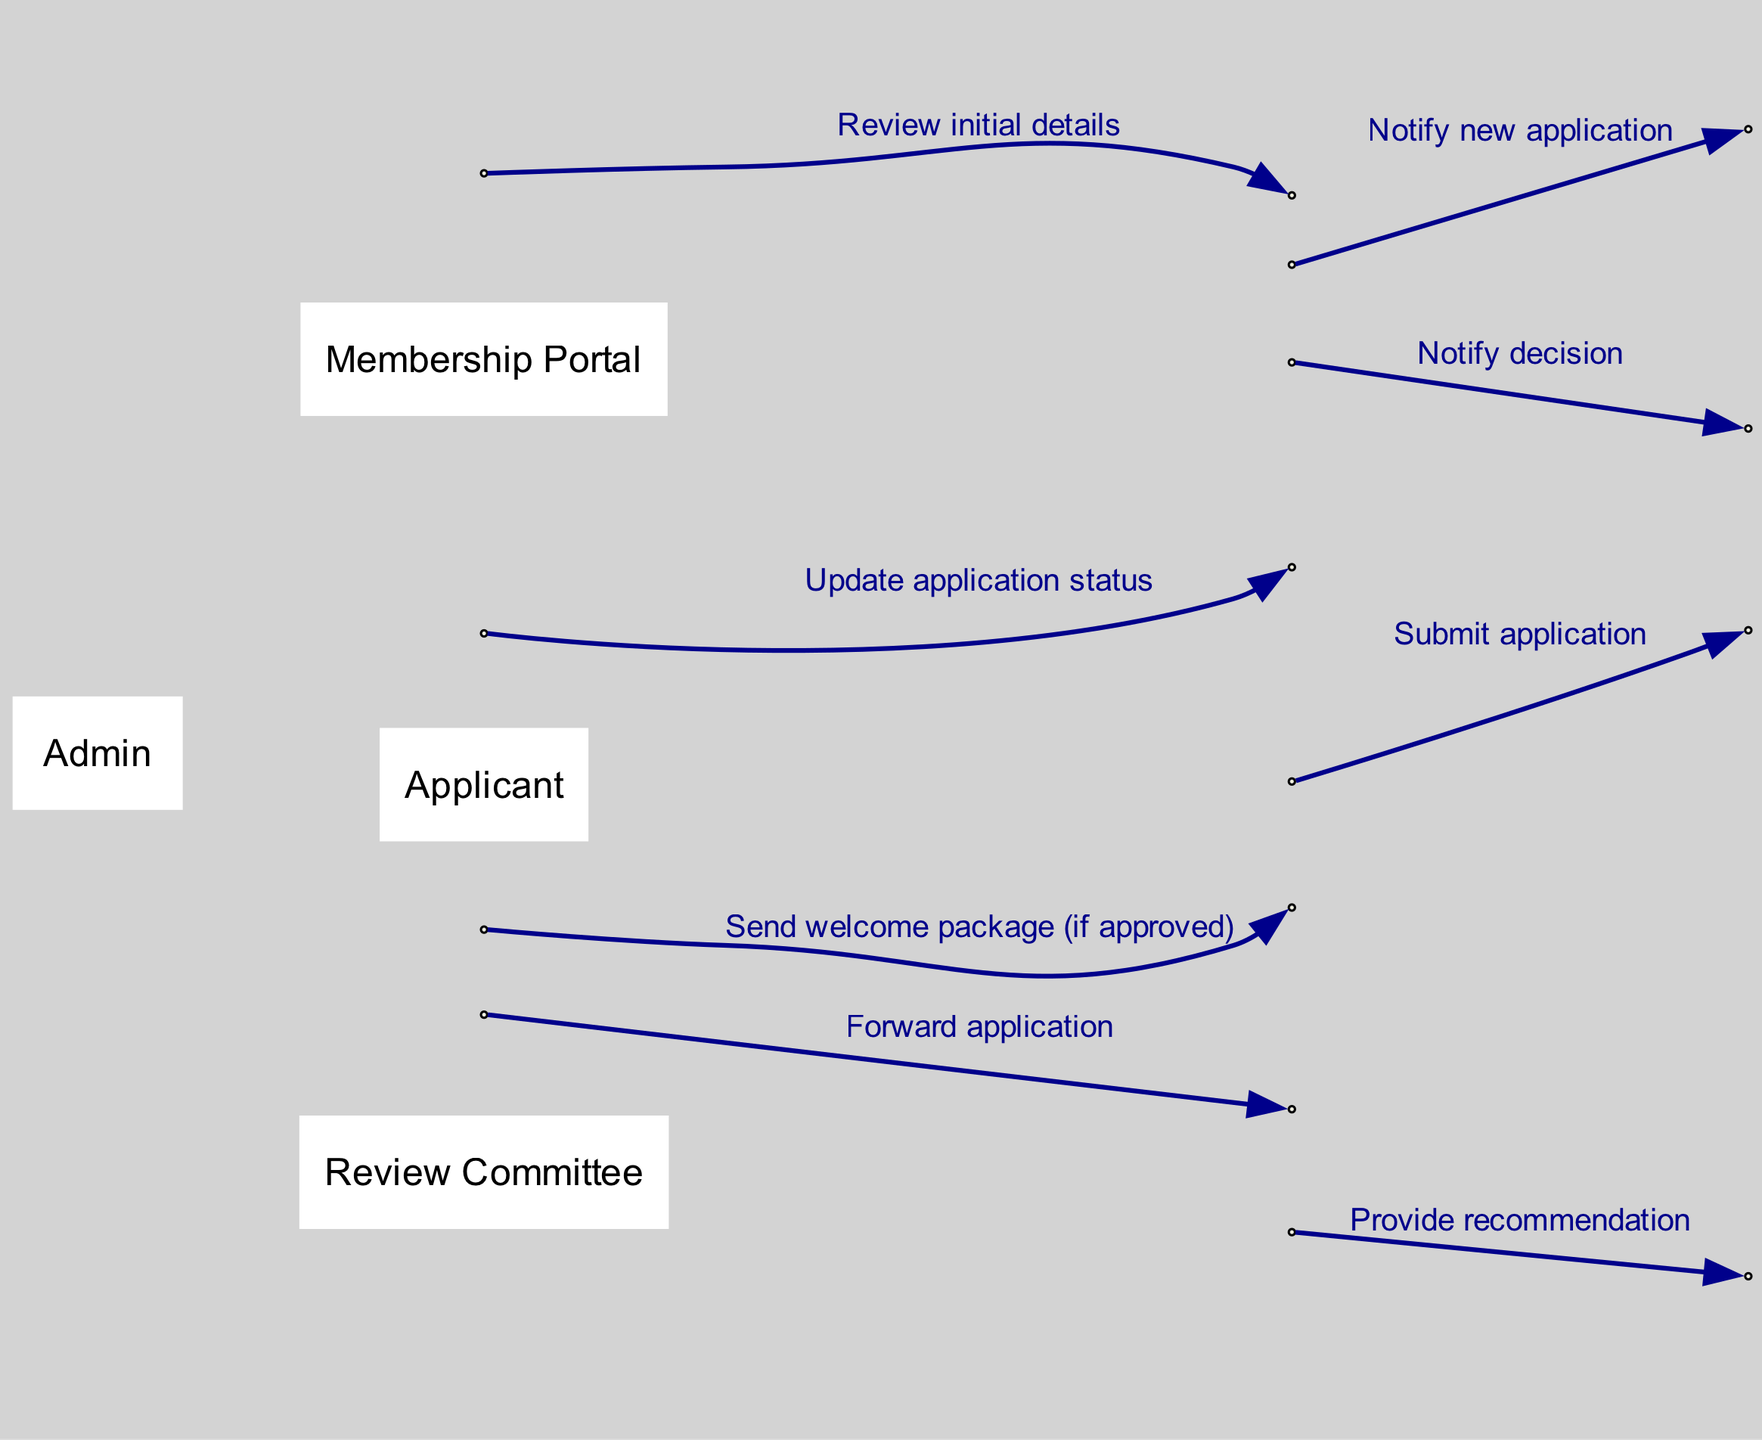What is the first action taken in the process? The first action in the process is depicted as the "Submit application" step, which initiates the sequence of events. This action occurs between the Applicant and the Membership Portal.
Answer: Submit application Who does the Admin forward the application to? According to the sequence diagram, after the Admin reviews the initial details of the application, the next action is to forward the application to the Review Committee.
Answer: Review Committee How many actors are involved in the process? The diagram identifies four distinct actors involved in the membership application and approval process, namely Applicant, Membership Portal, Admin, and Review Committee.
Answer: Four What action does the Membership Portal take after the Admin reviews the initial details? The Membership Portal's next action, after being notified by the Admin, is to update the application status, indicating a transition in the process as part of the overall workflow.
Answer: Update application status What is the last action taken if the application is approved? If the application is approved, the last action taken is to send a welcome package to the applicant, which concludes the approval process for the membership application.
Answer: Send welcome package (if approved) What do Admin and Review Committee exchange at their interaction? The Admin forwards the application to the Review Committee, and in return, the Review Committee provides a recommendation back to the Admin, illustrating a two-way exchange of information between these two actors.
Answer: Provide recommendation How many total actions are there in the sequence? By counting the steps detailed in the sequence, there are a total of eight distinct actions that make up the entire membership application and approval process.
Answer: Eight What does the last action before notifying the applicant entail? Before notifying the applicant, the Admin updates the application status, which is a crucial step that ensures the applicant is informed of their current status in the membership process.
Answer: Update application status 